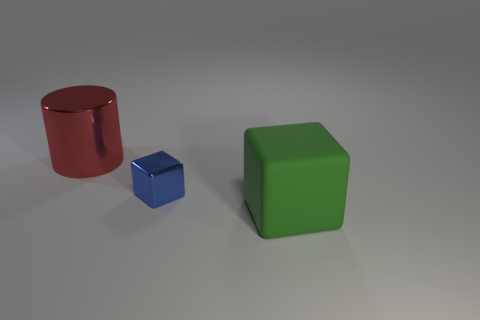What is the material of the tiny thing that is the same shape as the big green matte thing?
Your answer should be very brief. Metal. Does the cube that is behind the green cube have the same material as the large thing that is in front of the large metallic thing?
Your answer should be compact. No. What size is the object that is on the left side of the big matte thing and right of the large red thing?
Your answer should be compact. Small. What material is the object that is the same size as the red cylinder?
Keep it short and to the point. Rubber. There is a big thing that is right of the metallic thing that is on the right side of the red cylinder; how many big things are behind it?
Give a very brief answer. 1. There is a cube that is on the right side of the small metallic cube; does it have the same color as the metallic object in front of the red shiny thing?
Offer a terse response. No. What is the color of the thing that is behind the green object and on the right side of the big metal cylinder?
Give a very brief answer. Blue. What number of shiny things are the same size as the green matte object?
Ensure brevity in your answer.  1. There is a thing in front of the metallic thing that is on the right side of the cylinder; what shape is it?
Provide a short and direct response. Cube. What shape is the large object to the right of the metal thing left of the cube behind the big green rubber cube?
Provide a succinct answer. Cube. 